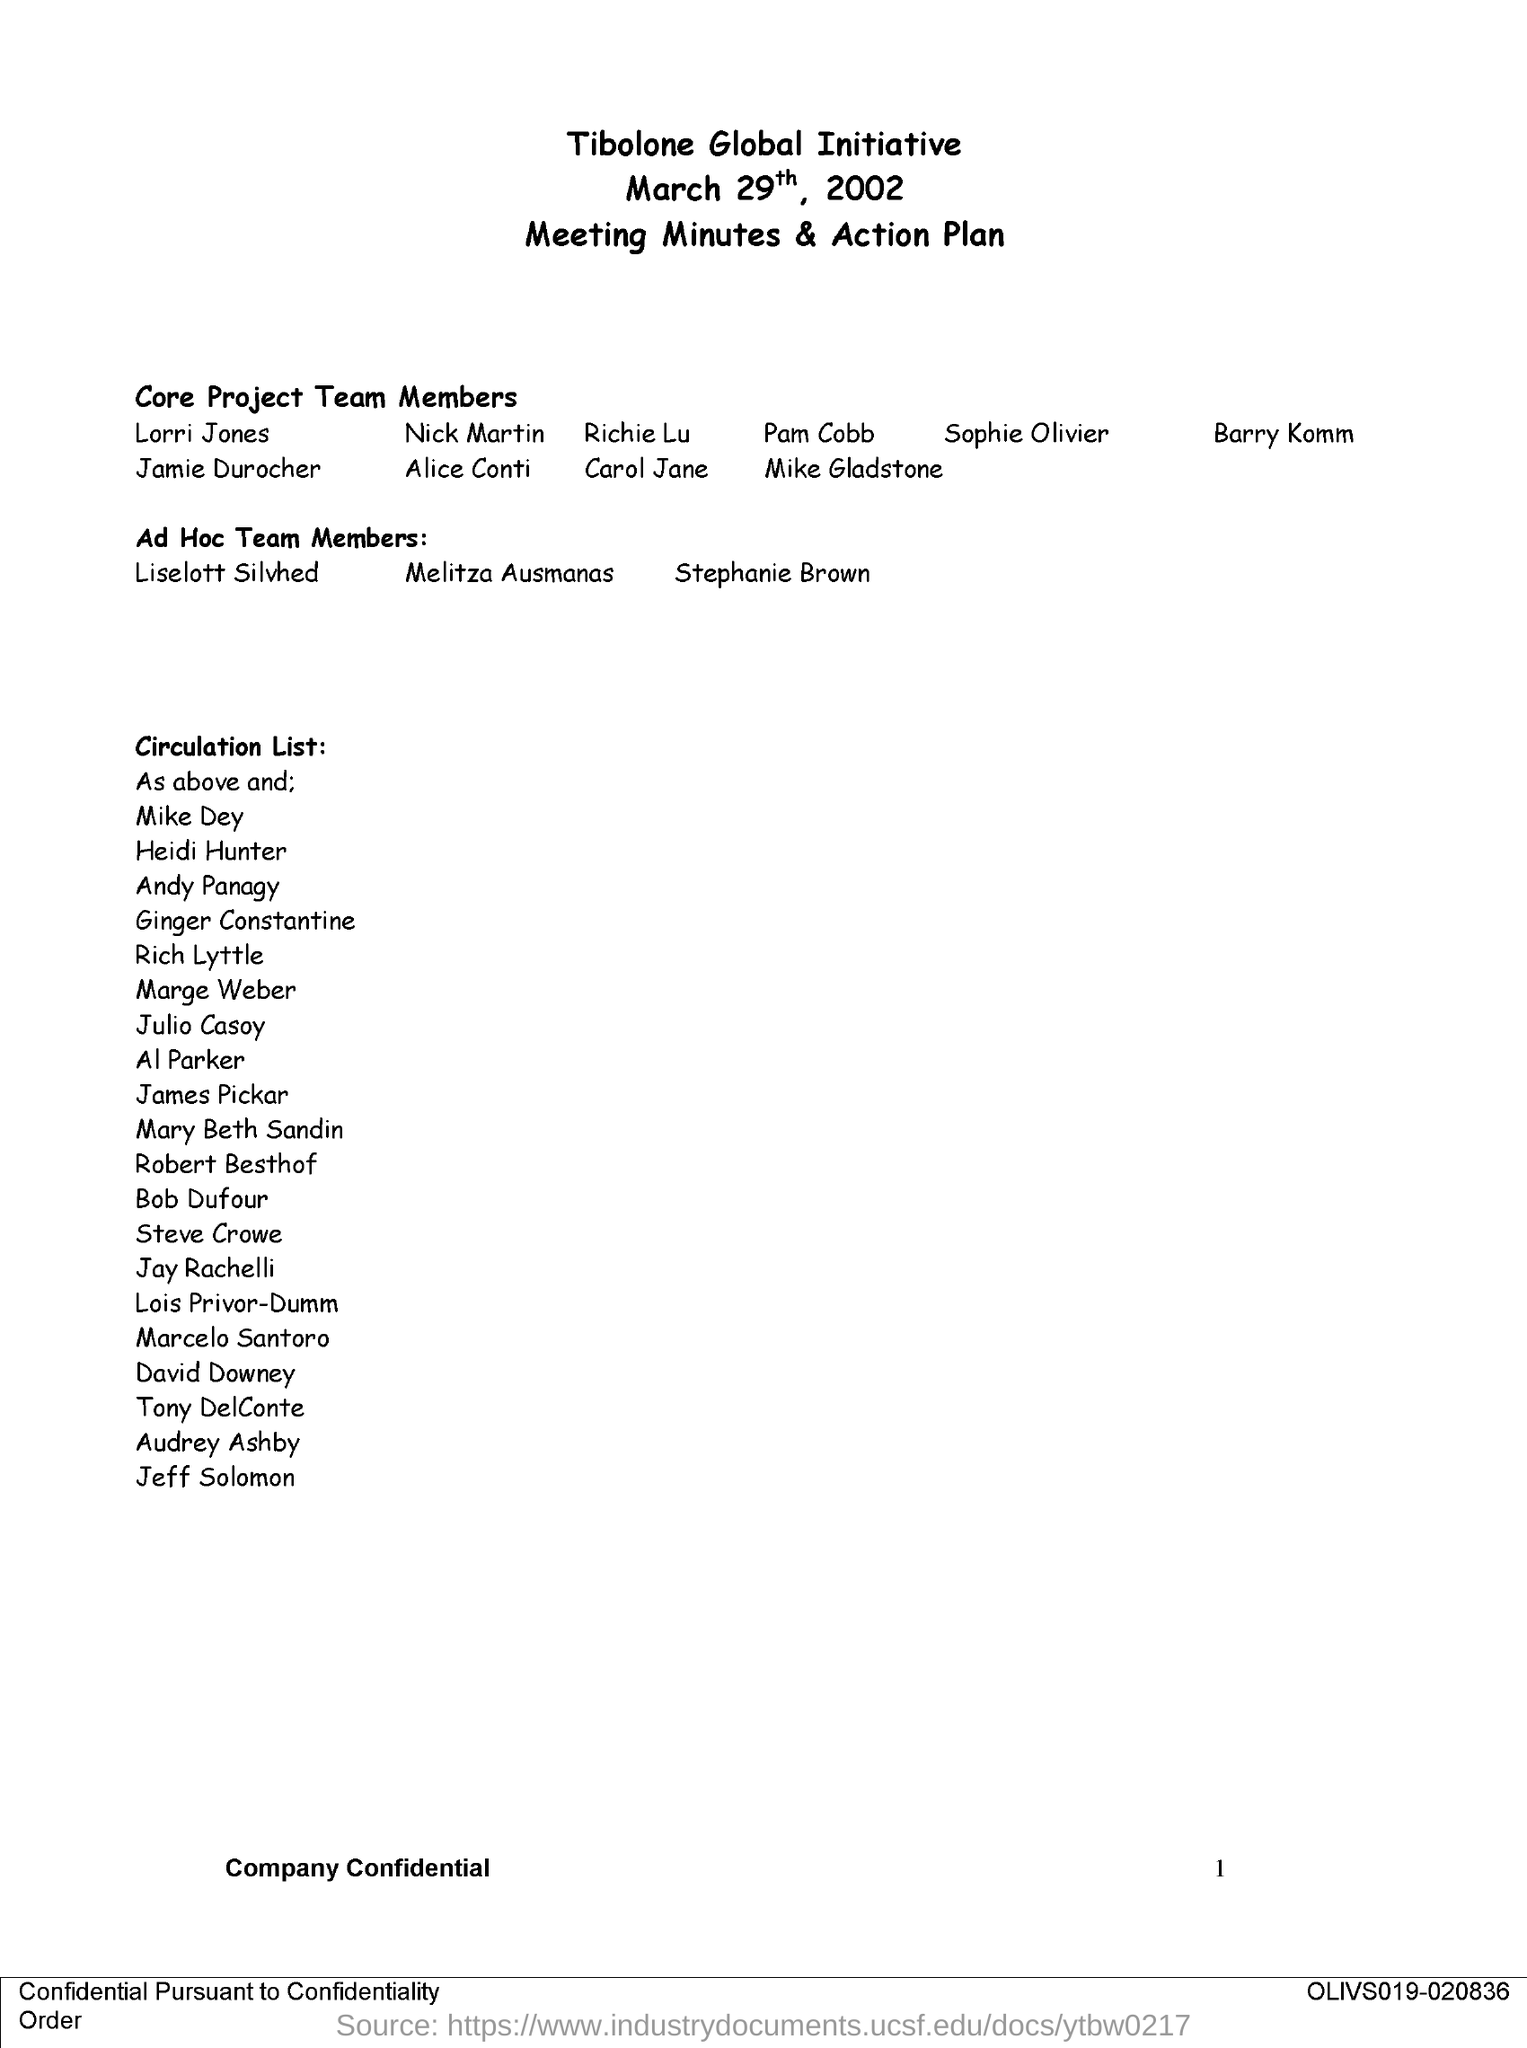Outline some significant characteristics in this image. The date on the document is March 29th, 2002. 